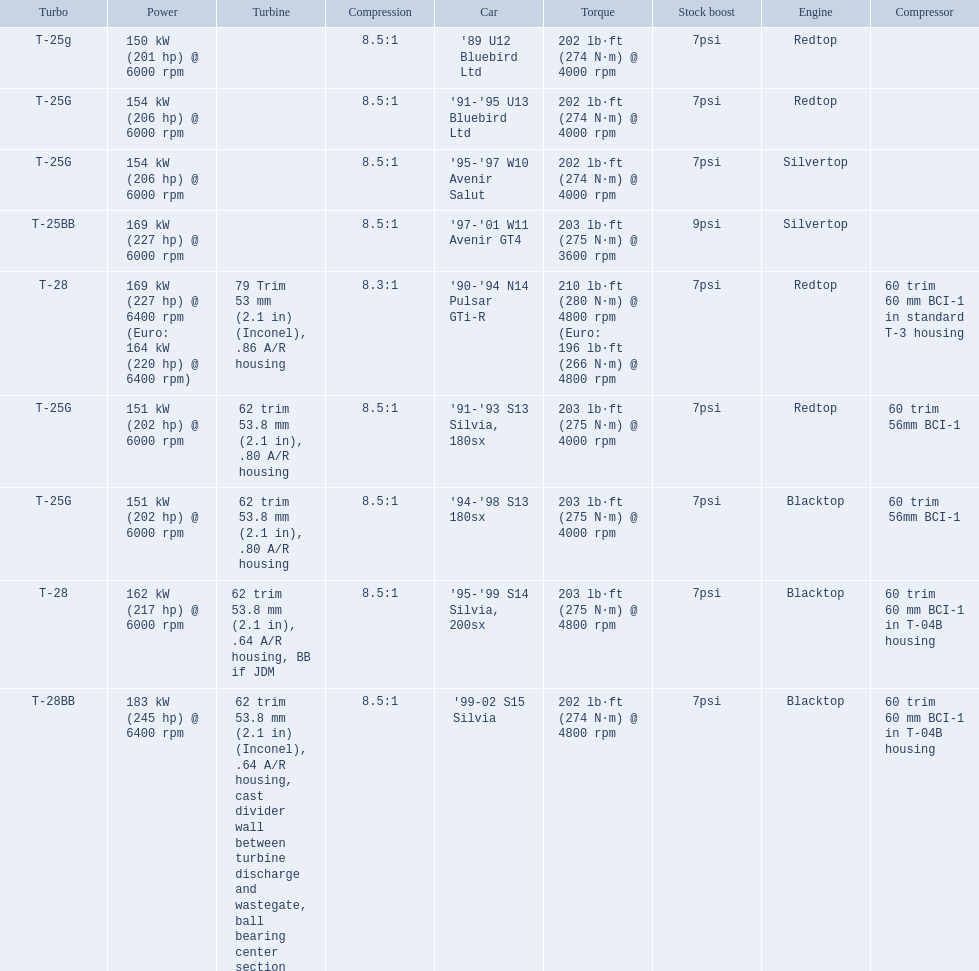What are all the cars? '89 U12 Bluebird Ltd, '91-'95 U13 Bluebird Ltd, '95-'97 W10 Avenir Salut, '97-'01 W11 Avenir GT4, '90-'94 N14 Pulsar GTi-R, '91-'93 S13 Silvia, 180sx, '94-'98 S13 180sx, '95-'99 S14 Silvia, 200sx, '99-02 S15 Silvia. What are their stock boosts? 7psi, 7psi, 7psi, 9psi, 7psi, 7psi, 7psi, 7psi, 7psi. And which car has the highest stock boost? '97-'01 W11 Avenir GT4. 